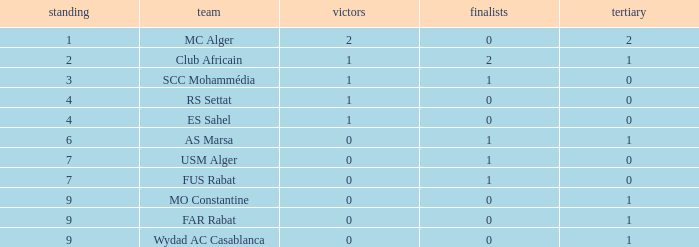Which Winners is the highest one that has a Rank larger than 7, and a Third smaller than 1? None. 